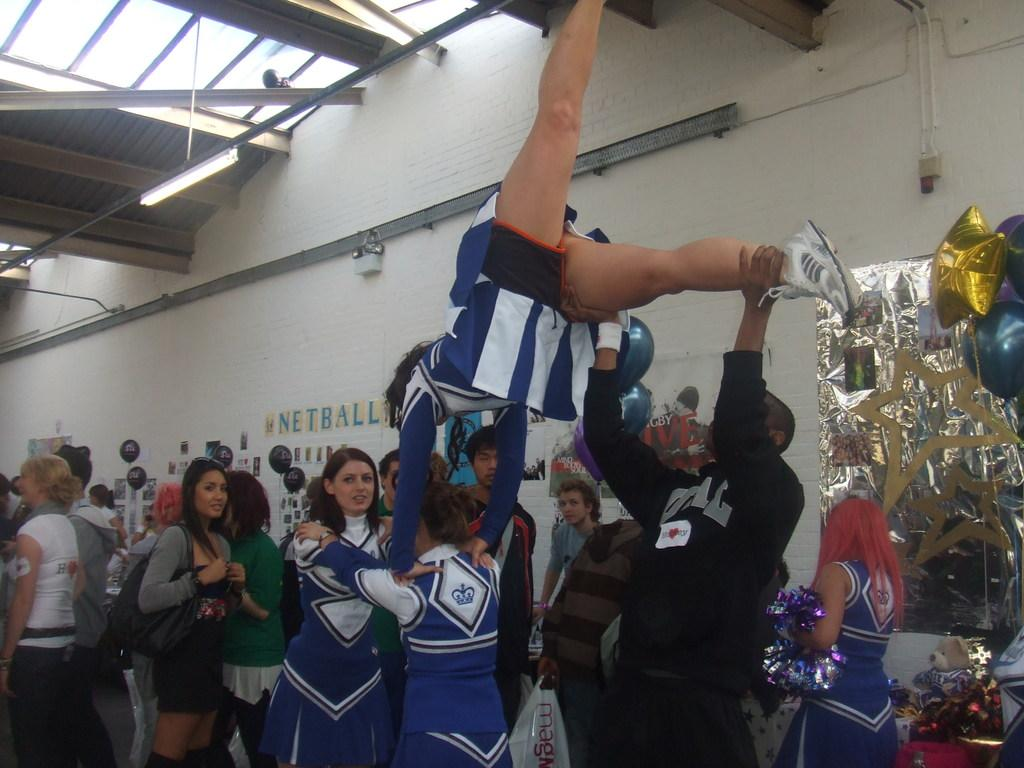<image>
Render a clear and concise summary of the photo. The girls are doing tricks in front of a wall that has the word Netball. 